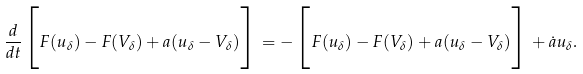<formula> <loc_0><loc_0><loc_500><loc_500>\frac { d } { d t } \Big { [ } F ( u _ { \delta } ) - F ( V _ { \delta } ) + a ( u _ { \delta } - V _ { \delta } ) \Big { ] } = - \Big { [ } F ( u _ { \delta } ) - F ( V _ { \delta } ) + a ( u _ { \delta } - V _ { \delta } ) \Big { ] } + \dot { a } u _ { \delta } .</formula> 